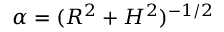<formula> <loc_0><loc_0><loc_500><loc_500>\alpha = ( R ^ { 2 } + H ^ { 2 } ) ^ { - 1 / 2 }</formula> 